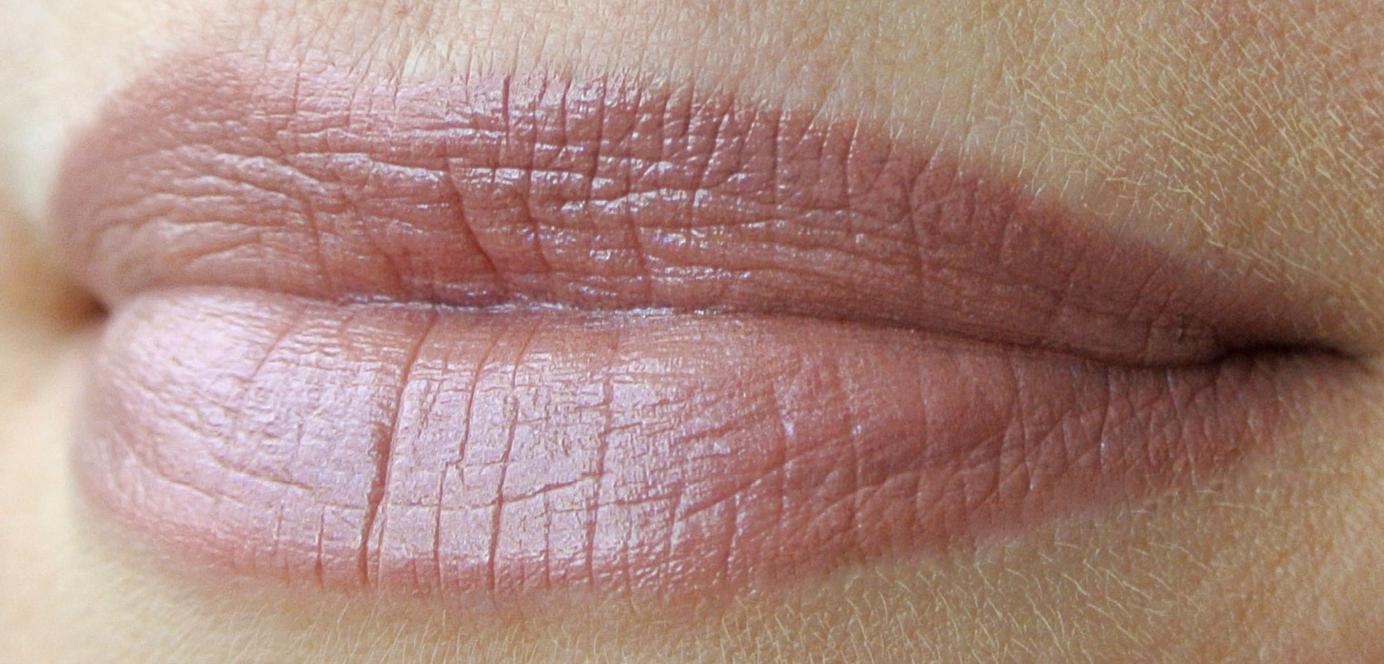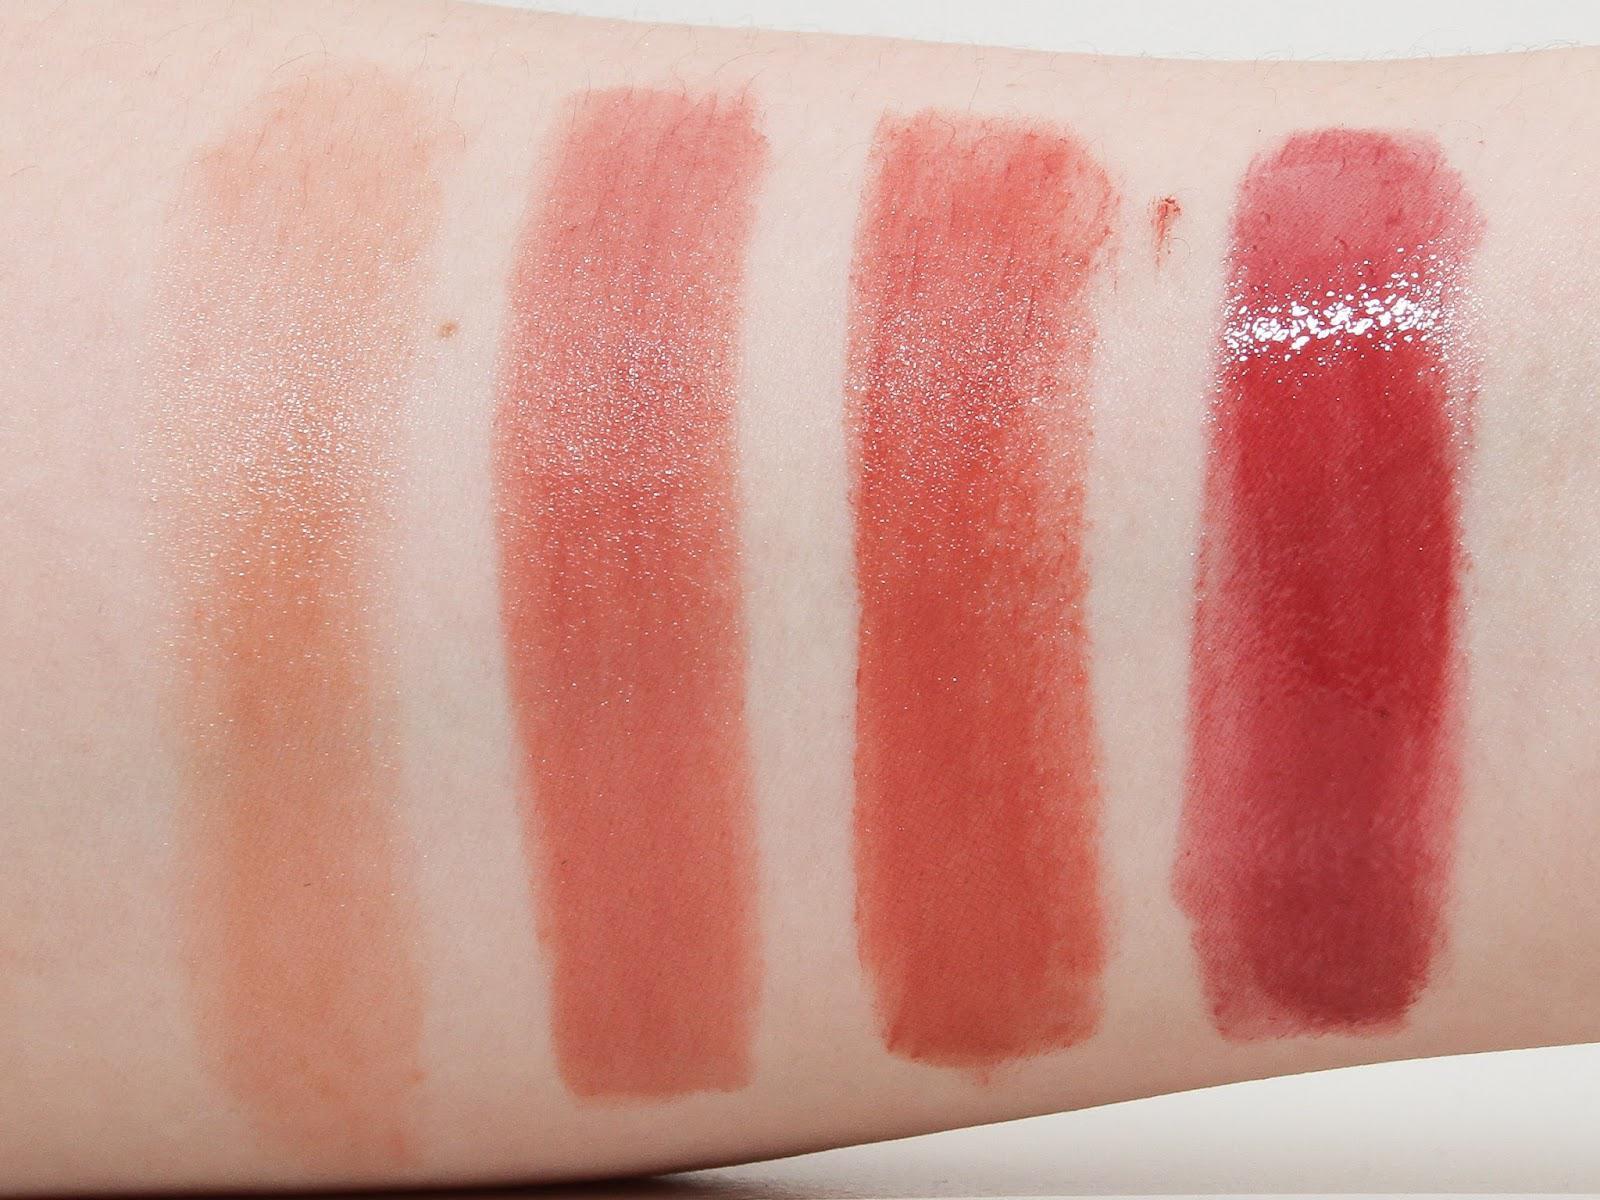The first image is the image on the left, the second image is the image on the right. Analyze the images presented: Is the assertion "One image features pink tinted lips with no teeth showing, and the other image shows multiple lipstick marks on skin." valid? Answer yes or no. Yes. The first image is the image on the left, the second image is the image on the right. Given the left and right images, does the statement "One image shows a lipstick shade displayed on lips and the other shows a variety of shades displayed on an arm." hold true? Answer yes or no. Yes. 